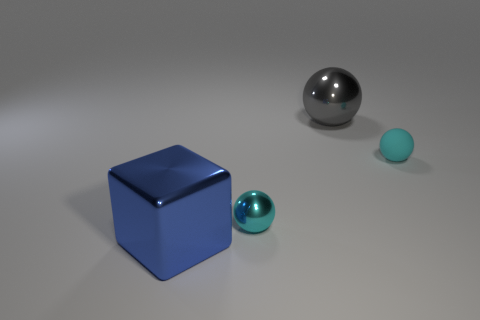Is there another large thing that has the same shape as the cyan rubber thing?
Provide a succinct answer. Yes. What number of objects are either tiny cyan shiny things or spheres on the left side of the gray thing?
Your answer should be very brief. 1. How many things are either large gray balls or small red rubber balls?
Provide a short and direct response. 1. Are there more small cyan objects that are in front of the cyan matte object than gray spheres on the right side of the big gray metallic object?
Provide a succinct answer. Yes. Is the color of the tiny thing that is left of the gray sphere the same as the large metal thing that is to the right of the blue shiny object?
Make the answer very short. No. There is a blue metallic thing to the left of the large object on the right side of the metallic sphere in front of the rubber ball; what is its size?
Your answer should be very brief. Large. What color is the other metal object that is the same shape as the small metallic thing?
Provide a short and direct response. Gray. Are there more tiny cyan metal objects on the left side of the gray shiny sphere than yellow shiny cylinders?
Provide a short and direct response. Yes. There is a rubber object; is its shape the same as the large shiny thing that is to the right of the blue thing?
Offer a terse response. Yes. There is another shiny object that is the same shape as the cyan metal object; what is its size?
Provide a short and direct response. Large. 